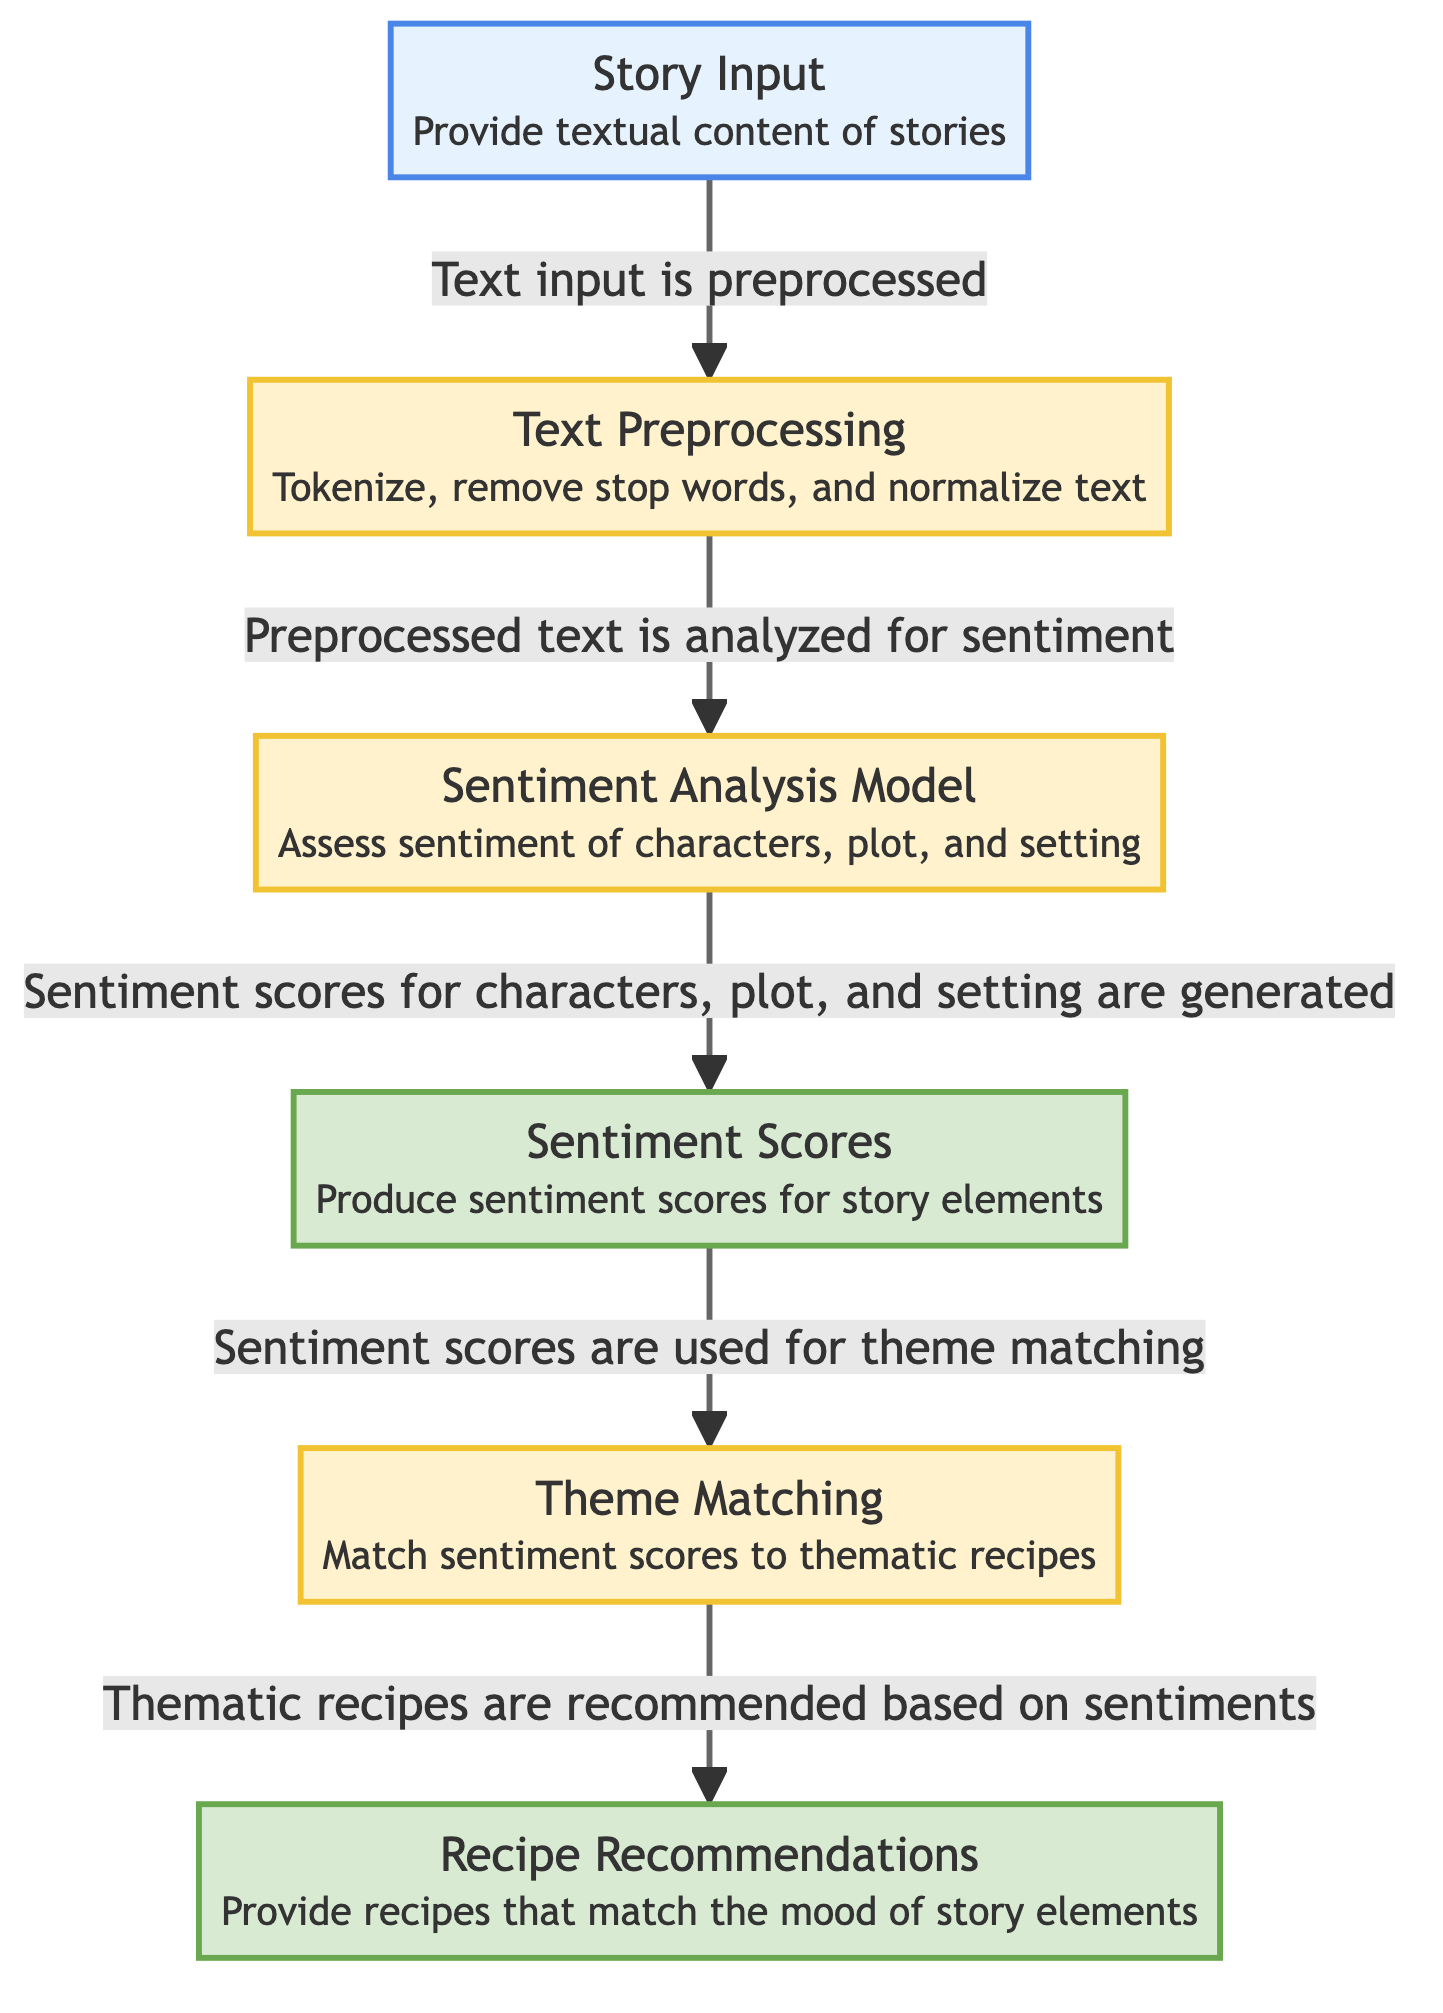What is the first step in the diagram? The first step in the diagram is labeled "Story Input," which involves providing the textual content of stories. This is indicated as the starting point of the flowchart, from where the process begins.
Answer: Story Input How many output nodes are present in the diagram? The diagram contains two output nodes: "Sentiment Scores" and "Recipe Recommendations." These are the results produced after processing the input through the various steps in the model.
Answer: 2 What does the "Text Preprocessing" step involve? The "Text Preprocessing" step involves tokenizing the text, removing stop words, and normalizing the text, as mentioned in the description of that node. This is a crucial step before conducting sentiment analysis.
Answer: Tokenize, remove stop words, normalize text What is the relationship between "Sentiment Analysis Model" and "Sentiment Scores"? The relationship indicates that the "Sentiment Analysis Model" analyzes the preprocessed text and generates "Sentiment Scores" for the story elements, establishing a direct flow of information from one to the other.
Answer: Generates What is matched to produce "Recipe Recommendations"? The "Sentiment Scores" from the assessment of characters, plot, and setting are matched to thematic recipes in the step labeled "Theme Matching," leading to the final output of recipe recommendations.
Answer: Sentiment Scores What components are assessed in the "Sentiment Analysis Model"? The "Sentiment Analysis Model" assesses the sentiment of three components: characters, plot, and setting. Each of these elements plays a role in determining the overall mood of the story.
Answer: Characters, plot, setting How many processes are involved in the diagram? There are four processes involved in the diagram: "Text Preprocessing," "Sentiment Analysis Model," "Theme Matching," and the final output of "Recipe Recommendations." Each step represents a specific function that contributes to the overall model.
Answer: 4 What type of analysis is being performed on the story elements? The diagram indicates that a sentiment analysis is performed on the story elements, which focuses on determining the emotional tone of characters, plot, and setting within the provided story text.
Answer: Sentiment analysis Which step comes after "Theme Matching"? After the "Theme Matching" step, the next step is "Recipe Recommendations," which provides the final output based on the matched sentiments and thematic connections. This indicates the flow of data and processing toward making recommendations.
Answer: Recipe Recommendations 